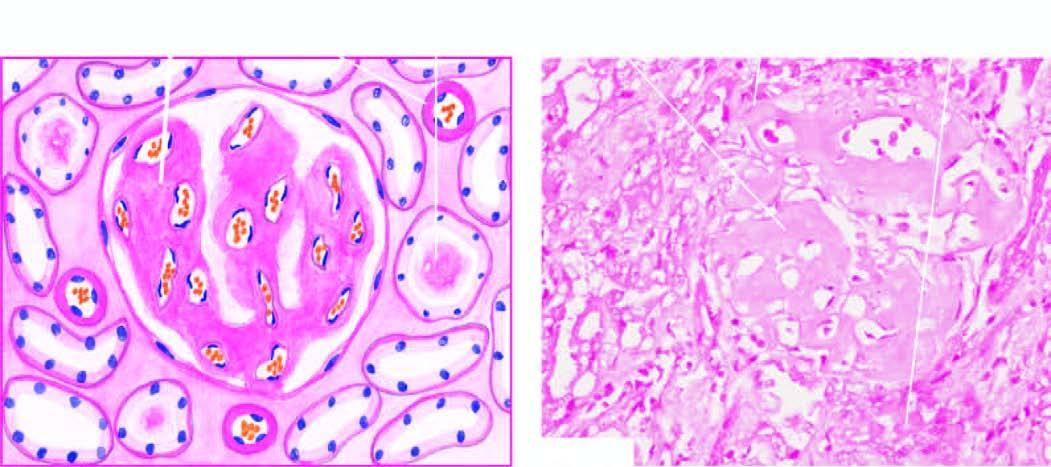what are also present in peritubular connective tissue producing atrophic tubules?
Answer the question using a single word or phrase. The deposits 